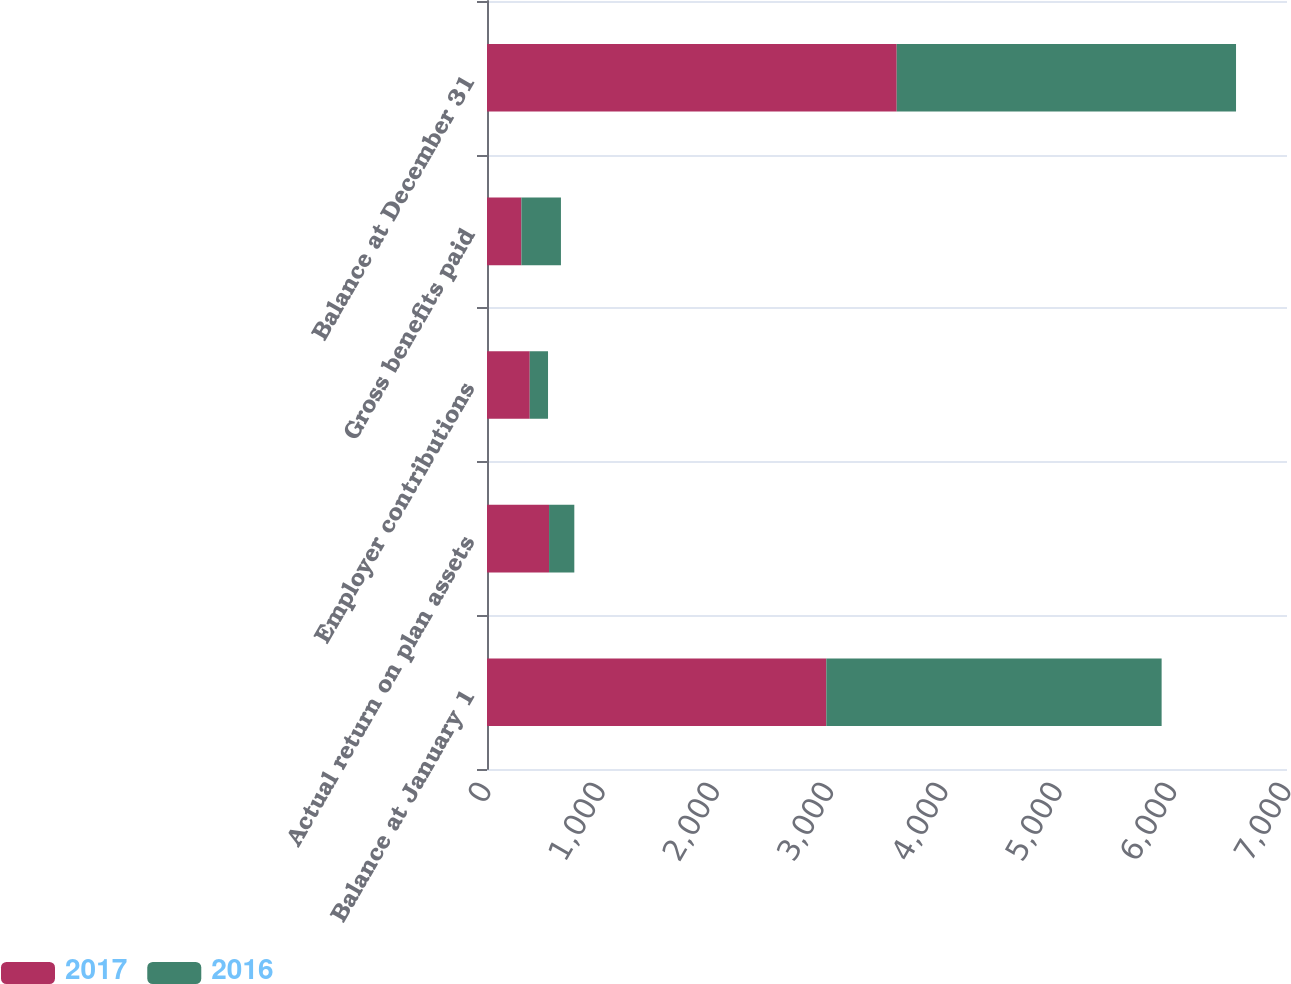Convert chart. <chart><loc_0><loc_0><loc_500><loc_500><stacked_bar_chart><ecel><fcel>Balance at January 1<fcel>Actual return on plan assets<fcel>Employer contributions<fcel>Gross benefits paid<fcel>Balance at December 31<nl><fcel>2017<fcel>2969<fcel>543<fcel>374<fcel>301<fcel>3585<nl><fcel>2016<fcel>2934<fcel>221<fcel>160<fcel>346<fcel>2969<nl></chart> 